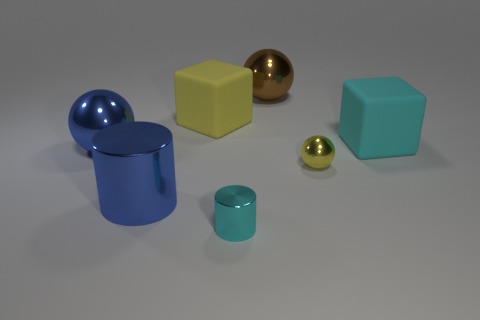Add 2 small blue metal balls. How many objects exist? 9 Subtract all big blue shiny balls. How many balls are left? 2 Subtract all brown balls. How many balls are left? 2 Subtract 2 blocks. How many blocks are left? 0 Subtract all blue cubes. Subtract all yellow cylinders. How many cubes are left? 2 Subtract 1 yellow balls. How many objects are left? 6 Subtract all cylinders. How many objects are left? 5 Subtract all brown balls. How many blue cylinders are left? 1 Subtract all tiny yellow shiny objects. Subtract all small cyan metal objects. How many objects are left? 5 Add 1 cyan matte objects. How many cyan matte objects are left? 2 